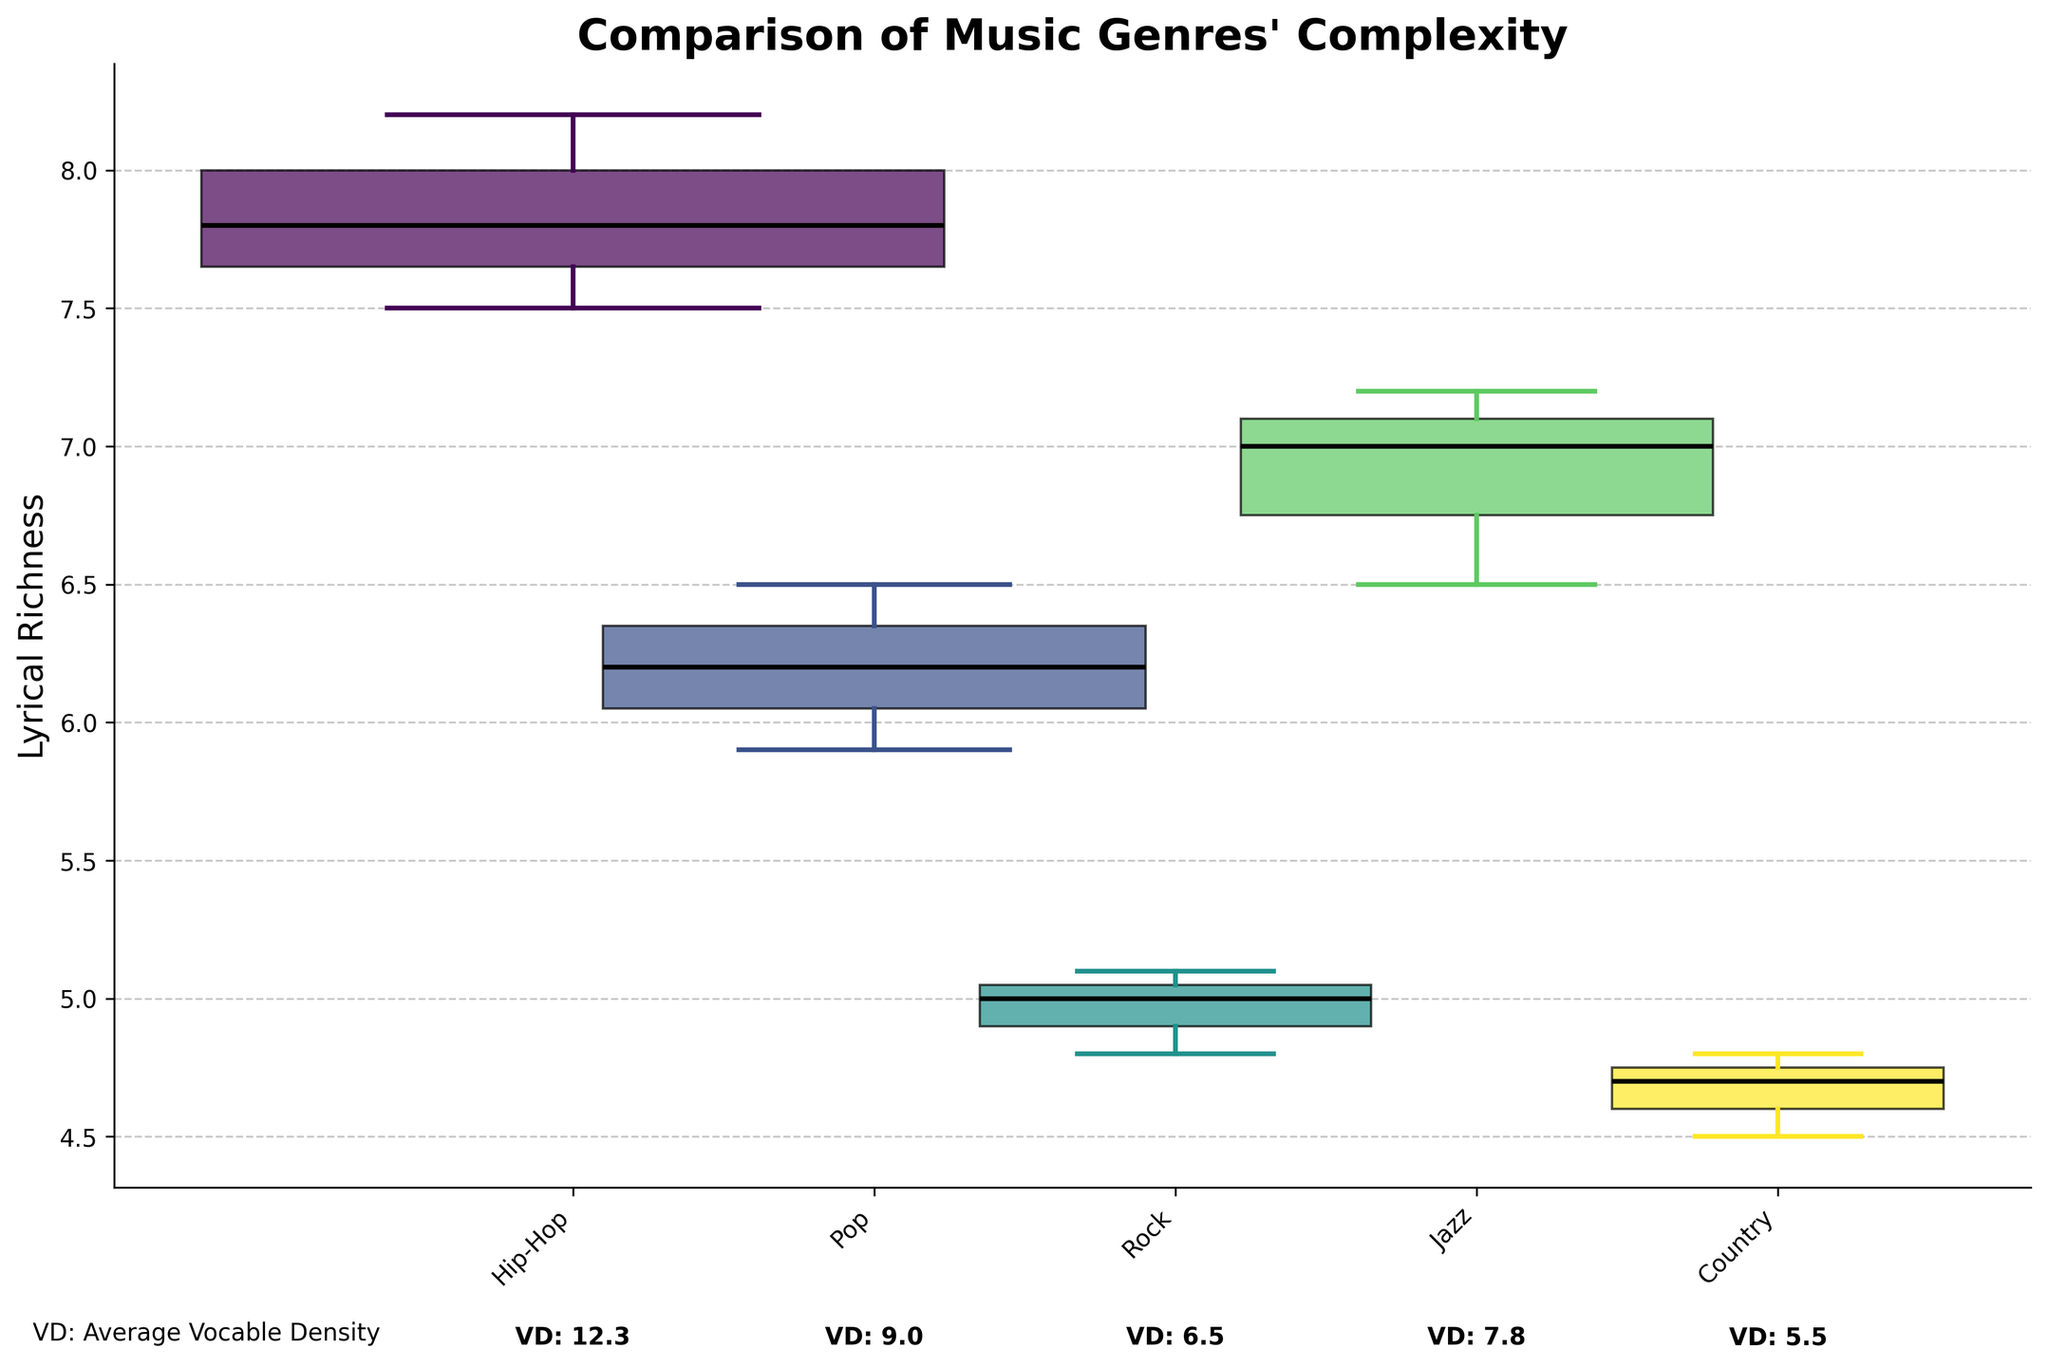What's the title of the plot? The title is usually displayed at the top of the plot and gives a summary of what the plot represents. By checking the top of the figure, we can find the title clearly stated.
Answer: "Comparison of Music Genres' Complexity" Which genre has the widest boxplot width and what is its Vocable Density? To determine this, look for the boxplot with the largest width, which represents the highest mean Vocable Density. The corresponding genre label below it will indicate the genre.
Answer: Hip-Hop, 12.3 What is the median Lyrical Richness of the Jazz genre? Check the thick black line within the boxplot for the Jazz genre, which represents the median value.
Answer: 7.0 Which genre has the lowest median Lyrical Richness? Observe all the boxplots and identify the one with the thick black line (median) at the lowest position.
Answer: Country What is the range of Lyrical Richness for the Rock genre? The range can be determined by subtracting the minimum value (lower whisker) from the maximum value (upper whisker) of the Rock genre boxplot.
Answer: 3.0 Compare the mean Vocable Density of Pop and Jazz genres. Which one is higher? To compare, look at the annotations below the x-axis for both Pop and Jazz genres, and identify which one has the higher value.
Answer: Pop Which genre(s) have overlapping interquartile ranges (IQR) with Jazz? Compare the boxes themselves (the IQRs) of other genres with Jazz. Overlapping ranges will indicate genres with similar distributions.
Answer: Hip-Hop, Pop How does the variability in Lyrical Richness in Hip-Hop compare to that in Rock? Variability is indicated by the width of the box (IQR) and the length of the whiskers. A larger spread means higher variability.
Answer: Hip-Hop has higher variability Based on the plot, which genre appears to have a more balanced distribution of Lyrical Richness? A more balanced distribution is indicated by a symmetrical boxplot with whiskers of similar length. Assess each genre for symmetry and balance.
Answer: Pop What's the average Vocable Density of the genres shown in the plot? To calculate the average, sum the mean Vocable Density values of all genres and divide by the number of genres. Mean values are indicated below the x-axis.
Answer: (12.3+9.0+6.5+7.8+5.5)/5 = 8.2 